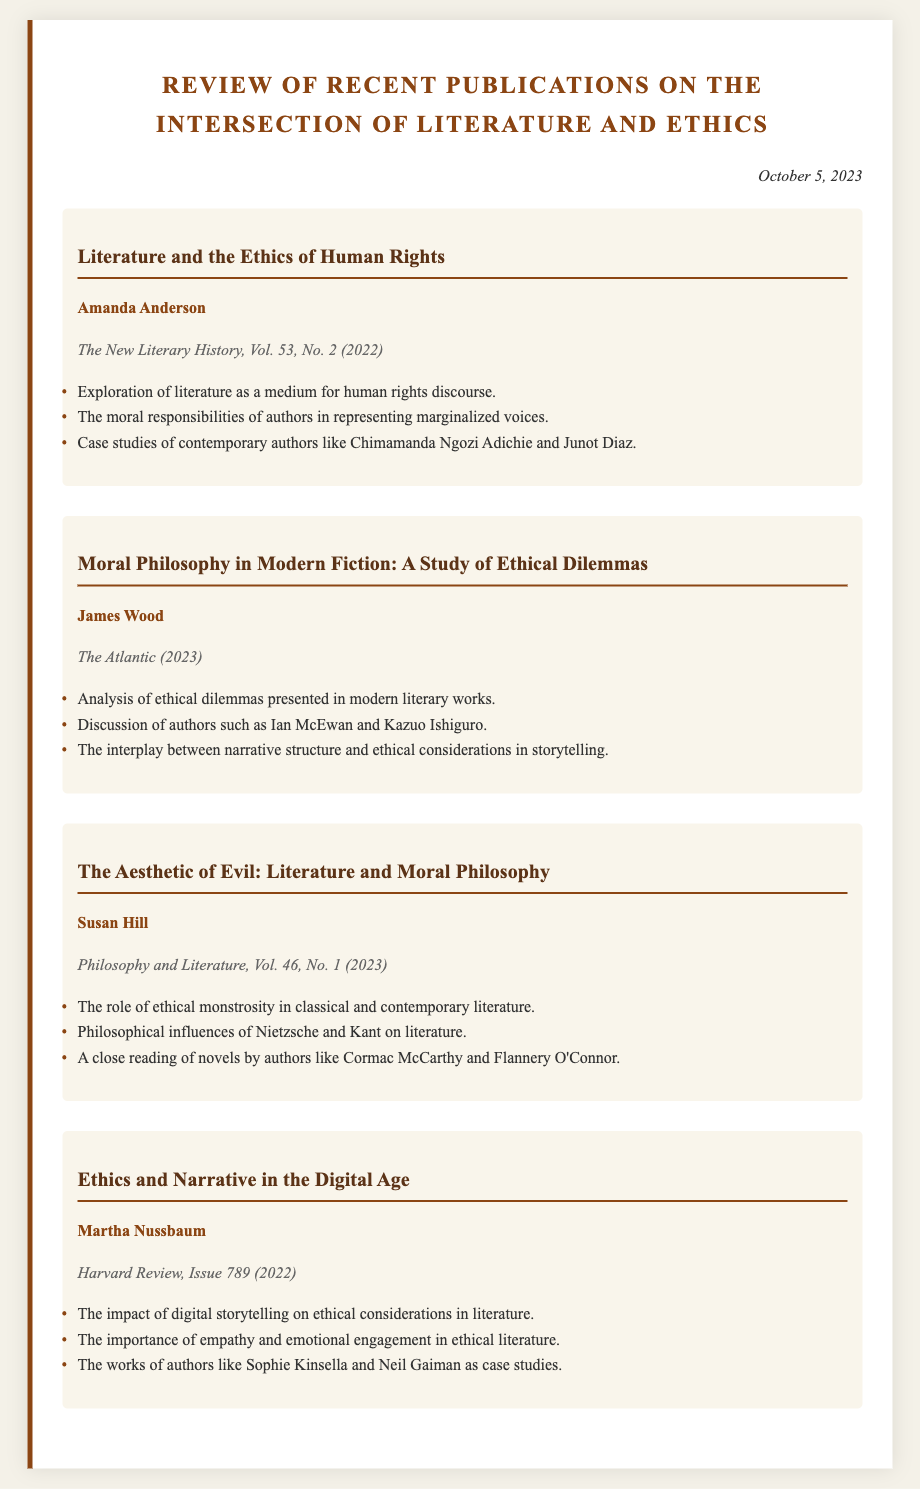What is the title of Amanda Anderson's publication? Amanda Anderson's publication is titled "Literature and the Ethics of Human Rights."
Answer: Literature and the Ethics of Human Rights Who authored "Moral Philosophy in Modern Fiction: A Study of Ethical Dilemmas"? The publication "Moral Philosophy in Modern Fiction: A Study of Ethical Dilemmas" is authored by James Wood.
Answer: James Wood In what year was "Ethics and Narrative in the Digital Age" published? "Ethics and Narrative in the Digital Age" was published in the year 2022.
Answer: 2022 Which author is discussed in relation to ethical monstrosity? Susan Hill discusses the role of ethical monstrosity in her publication.
Answer: Susan Hill What common theme is explored by Amanda Anderson and Martha Nussbaum? Both authors explore the representation of marginalized voices and the importance of empathy in literature.
Answer: Empathy and representation How many publications are reviewed in the memo? The memo reviews a total of four publications.
Answer: Four What is the publication type of "The Aesthetic of Evil: Literature and Moral Philosophy"? "The Aesthetic of Evil: Literature and Moral Philosophy" is published in the journal "Philosophy and Literature."
Answer: Philosophy and Literature Name one author associated with the examination of ethical dilemmas in modern fiction. Ian McEwan is one of the authors associated with ethical dilemmas in modern fiction.
Answer: Ian McEwan 